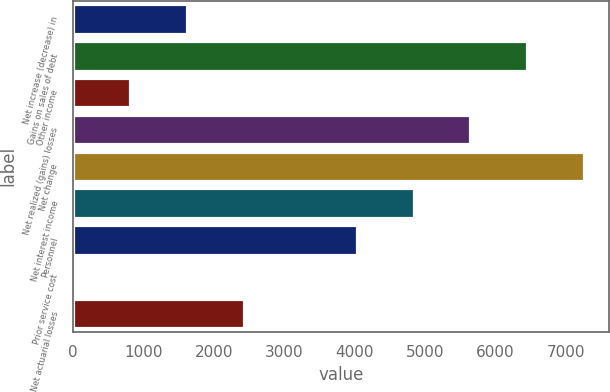<chart> <loc_0><loc_0><loc_500><loc_500><bar_chart><fcel>Net increase (decrease) in<fcel>Gains on sales of debt<fcel>Other income<fcel>Net realized (gains) losses<fcel>Net change<fcel>Net interest income<fcel>Personnel<fcel>Prior service cost<fcel>Net actuarial losses<nl><fcel>1616.8<fcel>6452.2<fcel>810.9<fcel>5646.3<fcel>7258.1<fcel>4840.4<fcel>4034.5<fcel>5<fcel>2422.7<nl></chart> 